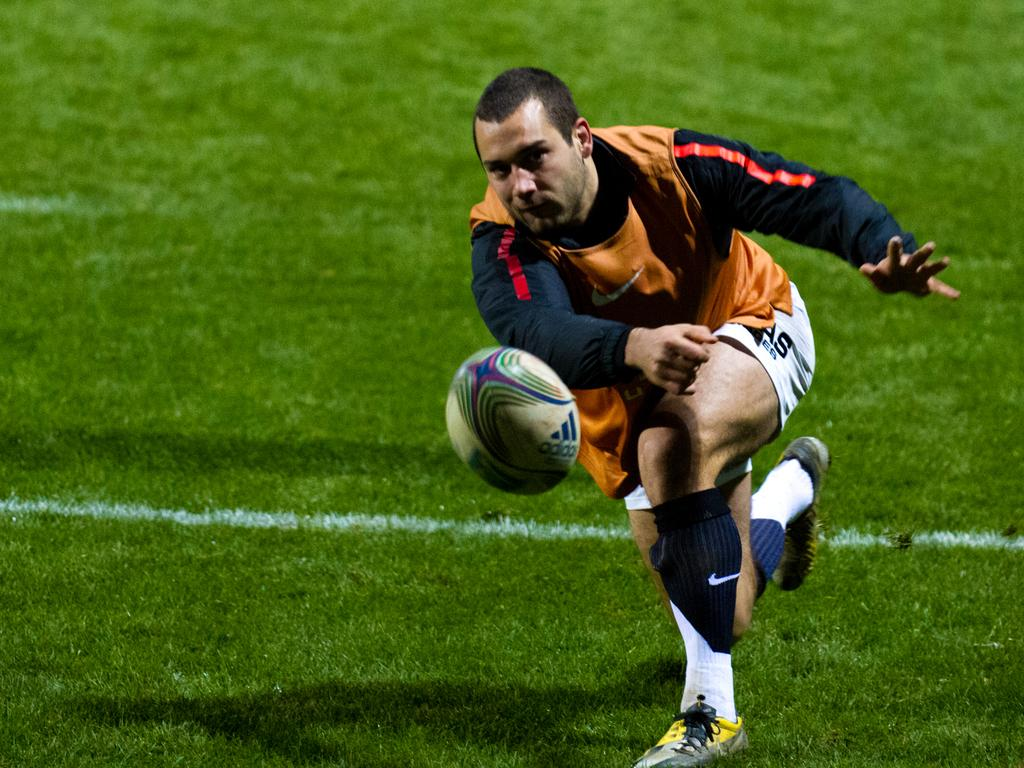What is the main subject of the image? There is a person in the image. What is the person doing in the image? The person is playing with a ball. Where is the ball located in the image? The ball is on the grass. What role does the manager play in the image? There is no manager present in the image; it only features a person playing with a ball on the grass. 